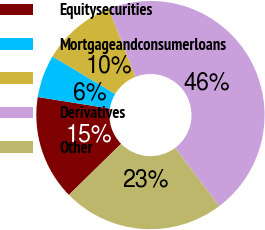Convert chart. <chart><loc_0><loc_0><loc_500><loc_500><pie_chart><fcel>Equitysecurities<fcel>Mortgageandconsumerloans<fcel>Unnamed: 2<fcel>Derivatives<fcel>Other<nl><fcel>14.86%<fcel>6.06%<fcel>10.46%<fcel>45.66%<fcel>22.95%<nl></chart> 